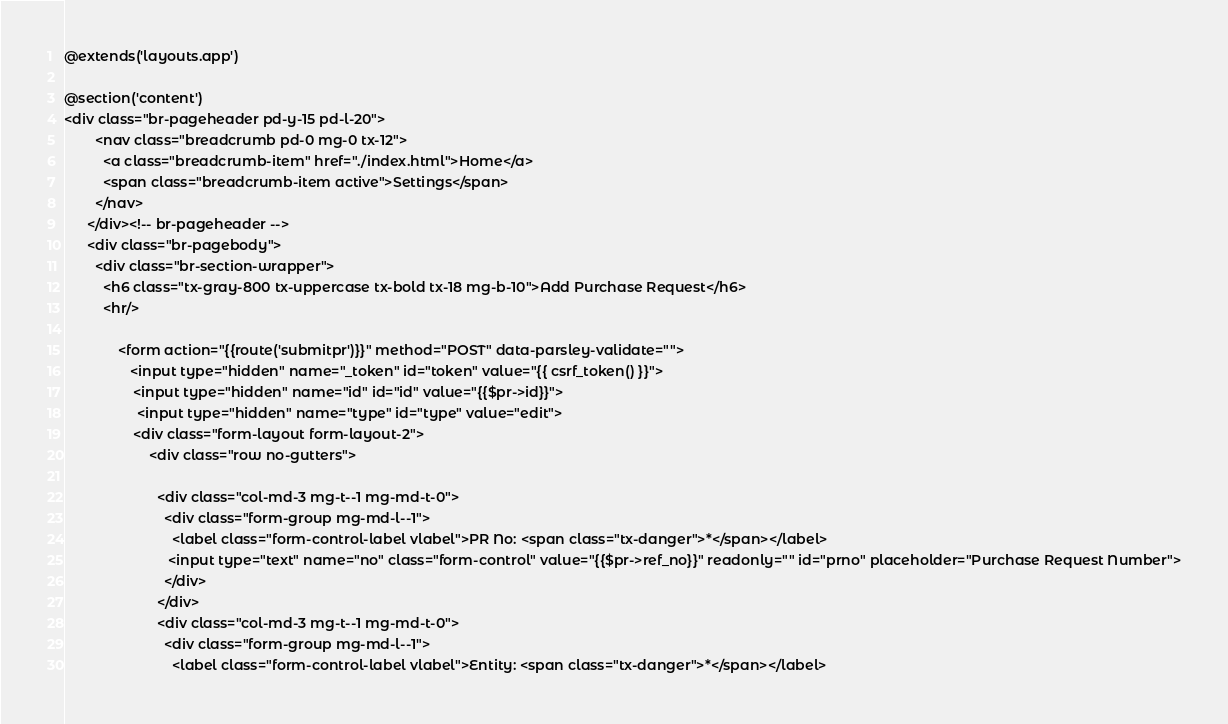<code> <loc_0><loc_0><loc_500><loc_500><_PHP_>@extends('layouts.app')

@section('content')
<div class="br-pageheader pd-y-15 pd-l-20">
        <nav class="breadcrumb pd-0 mg-0 tx-12">
          <a class="breadcrumb-item" href="./index.html">Home</a>
          <span class="breadcrumb-item active">Settings</span>
        </nav>
      </div><!-- br-pageheader -->
      <div class="br-pagebody">
        <div class="br-section-wrapper">
          <h6 class="tx-gray-800 tx-uppercase tx-bold tx-18 mg-b-10">Add Purchase Request</h6>
          <hr/>

              <form action="{{route('submitpr')}}" method="POST" data-parsley-validate="">
                 <input type="hidden" name="_token" id="token" value="{{ csrf_token() }}">
                  <input type="hidden" name="id" id="id" value="{{$pr->id}}">
                   <input type="hidden" name="type" id="type" value="edit">
                  <div class="form-layout form-layout-2">
                      <div class="row no-gutters">
                          
                        <div class="col-md-3 mg-t--1 mg-md-t-0">
                          <div class="form-group mg-md-l--1">
                            <label class="form-control-label vlabel">PR No: <span class="tx-danger">*</span></label>
                           <input type="text" name="no" class="form-control" value="{{$pr->ref_no}}" readonly="" id="prno" placeholder="Purchase Request Number">
                          </div>
                        </div>
                        <div class="col-md-3 mg-t--1 mg-md-t-0">
                          <div class="form-group mg-md-l--1">
                            <label class="form-control-label vlabel">Entity: <span class="tx-danger">*</span></label></code> 